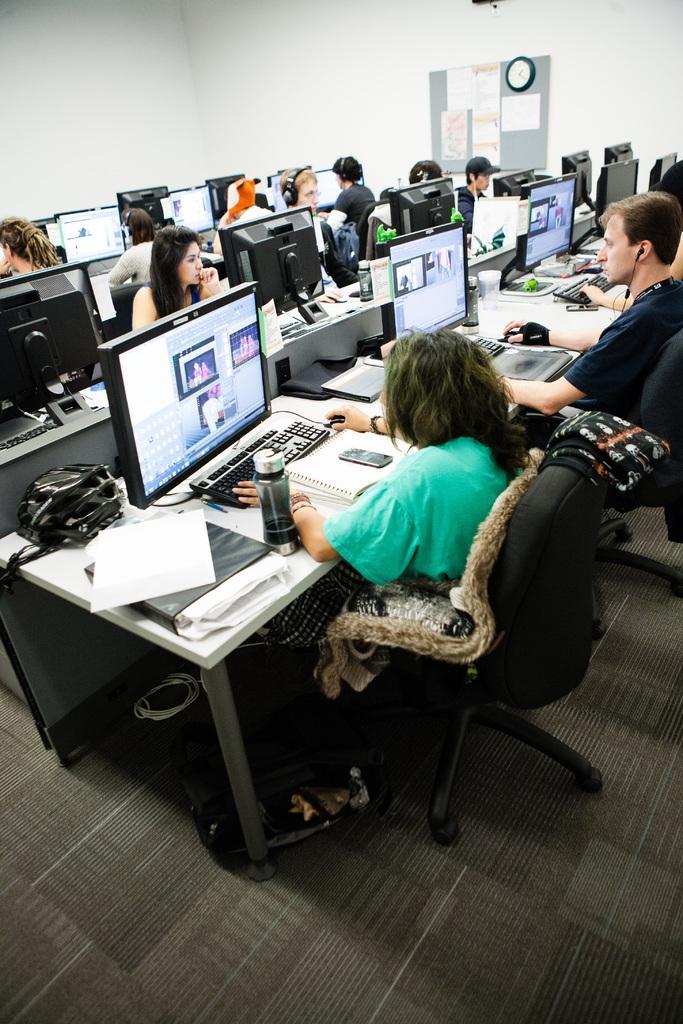In one or two sentences, can you explain what this image depicts? A picture inside of a office. Posters and clock on wall. These persons are sitting on chairs and working on monitors. In-front of them there are table, on this tables there are keyboards, monitors, bag, file, paper, mobile, book and bottle. On this chair there is a cloth. 